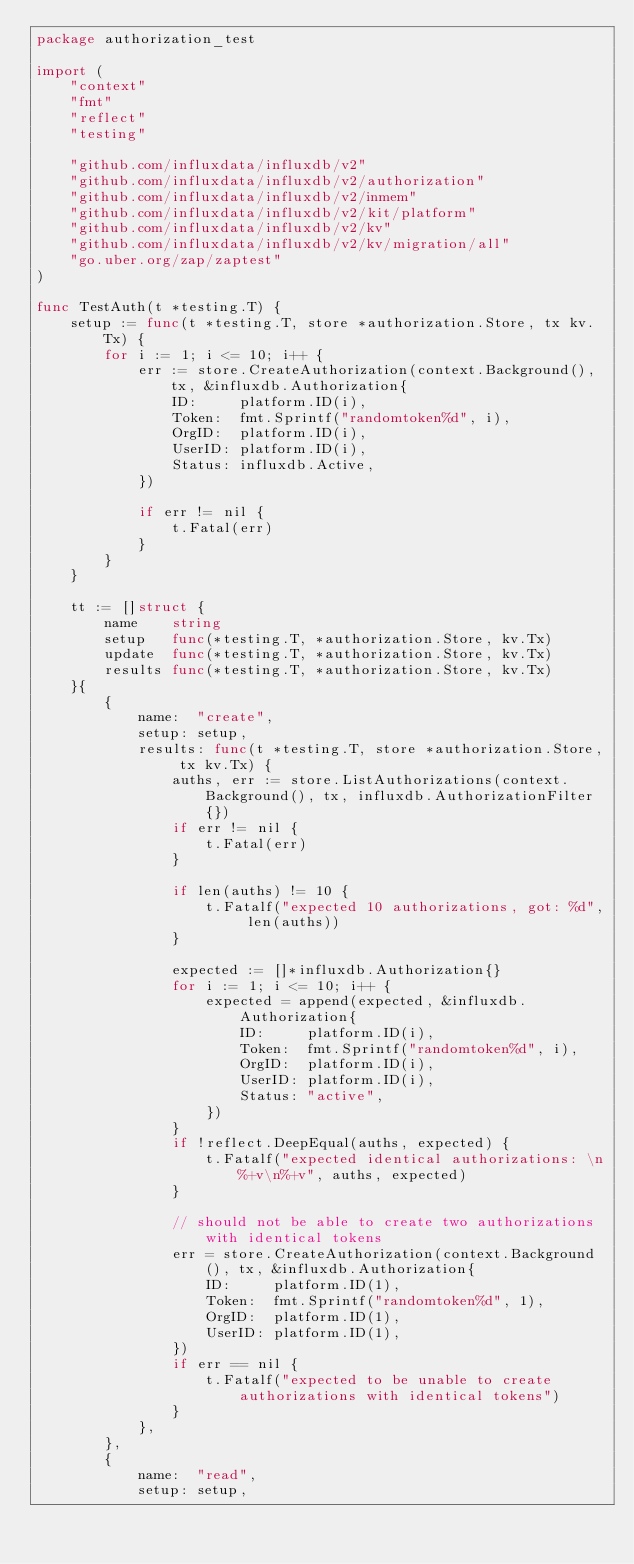Convert code to text. <code><loc_0><loc_0><loc_500><loc_500><_Go_>package authorization_test

import (
	"context"
	"fmt"
	"reflect"
	"testing"

	"github.com/influxdata/influxdb/v2"
	"github.com/influxdata/influxdb/v2/authorization"
	"github.com/influxdata/influxdb/v2/inmem"
	"github.com/influxdata/influxdb/v2/kit/platform"
	"github.com/influxdata/influxdb/v2/kv"
	"github.com/influxdata/influxdb/v2/kv/migration/all"
	"go.uber.org/zap/zaptest"
)

func TestAuth(t *testing.T) {
	setup := func(t *testing.T, store *authorization.Store, tx kv.Tx) {
		for i := 1; i <= 10; i++ {
			err := store.CreateAuthorization(context.Background(), tx, &influxdb.Authorization{
				ID:     platform.ID(i),
				Token:  fmt.Sprintf("randomtoken%d", i),
				OrgID:  platform.ID(i),
				UserID: platform.ID(i),
				Status: influxdb.Active,
			})

			if err != nil {
				t.Fatal(err)
			}
		}
	}

	tt := []struct {
		name    string
		setup   func(*testing.T, *authorization.Store, kv.Tx)
		update  func(*testing.T, *authorization.Store, kv.Tx)
		results func(*testing.T, *authorization.Store, kv.Tx)
	}{
		{
			name:  "create",
			setup: setup,
			results: func(t *testing.T, store *authorization.Store, tx kv.Tx) {
				auths, err := store.ListAuthorizations(context.Background(), tx, influxdb.AuthorizationFilter{})
				if err != nil {
					t.Fatal(err)
				}

				if len(auths) != 10 {
					t.Fatalf("expected 10 authorizations, got: %d", len(auths))
				}

				expected := []*influxdb.Authorization{}
				for i := 1; i <= 10; i++ {
					expected = append(expected, &influxdb.Authorization{
						ID:     platform.ID(i),
						Token:  fmt.Sprintf("randomtoken%d", i),
						OrgID:  platform.ID(i),
						UserID: platform.ID(i),
						Status: "active",
					})
				}
				if !reflect.DeepEqual(auths, expected) {
					t.Fatalf("expected identical authorizations: \n%+v\n%+v", auths, expected)
				}

				// should not be able to create two authorizations with identical tokens
				err = store.CreateAuthorization(context.Background(), tx, &influxdb.Authorization{
					ID:     platform.ID(1),
					Token:  fmt.Sprintf("randomtoken%d", 1),
					OrgID:  platform.ID(1),
					UserID: platform.ID(1),
				})
				if err == nil {
					t.Fatalf("expected to be unable to create authorizations with identical tokens")
				}
			},
		},
		{
			name:  "read",
			setup: setup,</code> 